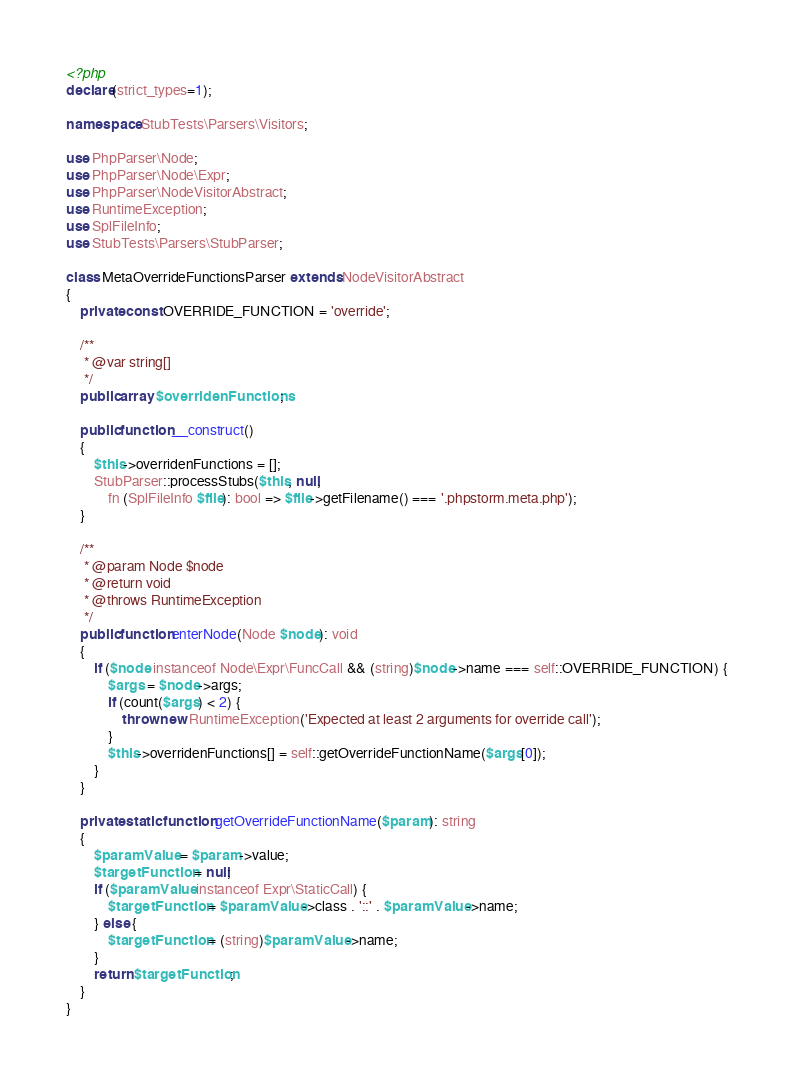<code> <loc_0><loc_0><loc_500><loc_500><_PHP_><?php
declare(strict_types=1);

namespace StubTests\Parsers\Visitors;

use PhpParser\Node;
use PhpParser\Node\Expr;
use PhpParser\NodeVisitorAbstract;
use RuntimeException;
use SplFileInfo;
use StubTests\Parsers\StubParser;

class MetaOverrideFunctionsParser extends NodeVisitorAbstract
{
    private const OVERRIDE_FUNCTION = 'override';

    /**
     * @var string[]
     */
    public array $overridenFunctions;

    public function __construct()
    {
        $this->overridenFunctions = [];
        StubParser::processStubs($this, null,
            fn (SplFileInfo $file): bool => $file->getFilename() === '.phpstorm.meta.php');
    }

    /**
     * @param Node $node
     * @return void
     * @throws RuntimeException
     */
    public function enterNode(Node $node): void
    {
        if ($node instanceof Node\Expr\FuncCall && (string)$node->name === self::OVERRIDE_FUNCTION) {
            $args = $node->args;
            if (count($args) < 2) {
                throw new RuntimeException('Expected at least 2 arguments for override call');
            }
            $this->overridenFunctions[] = self::getOverrideFunctionName($args[0]);
        }
    }

    private static function getOverrideFunctionName($param): string
    {
        $paramValue = $param->value;
        $targetFunction = null;
        if ($paramValue instanceof Expr\StaticCall) {
            $targetFunction = $paramValue->class . '::' . $paramValue->name;
        } else {
            $targetFunction = (string)$paramValue->name;
        }
        return $targetFunction;
    }
}
</code> 